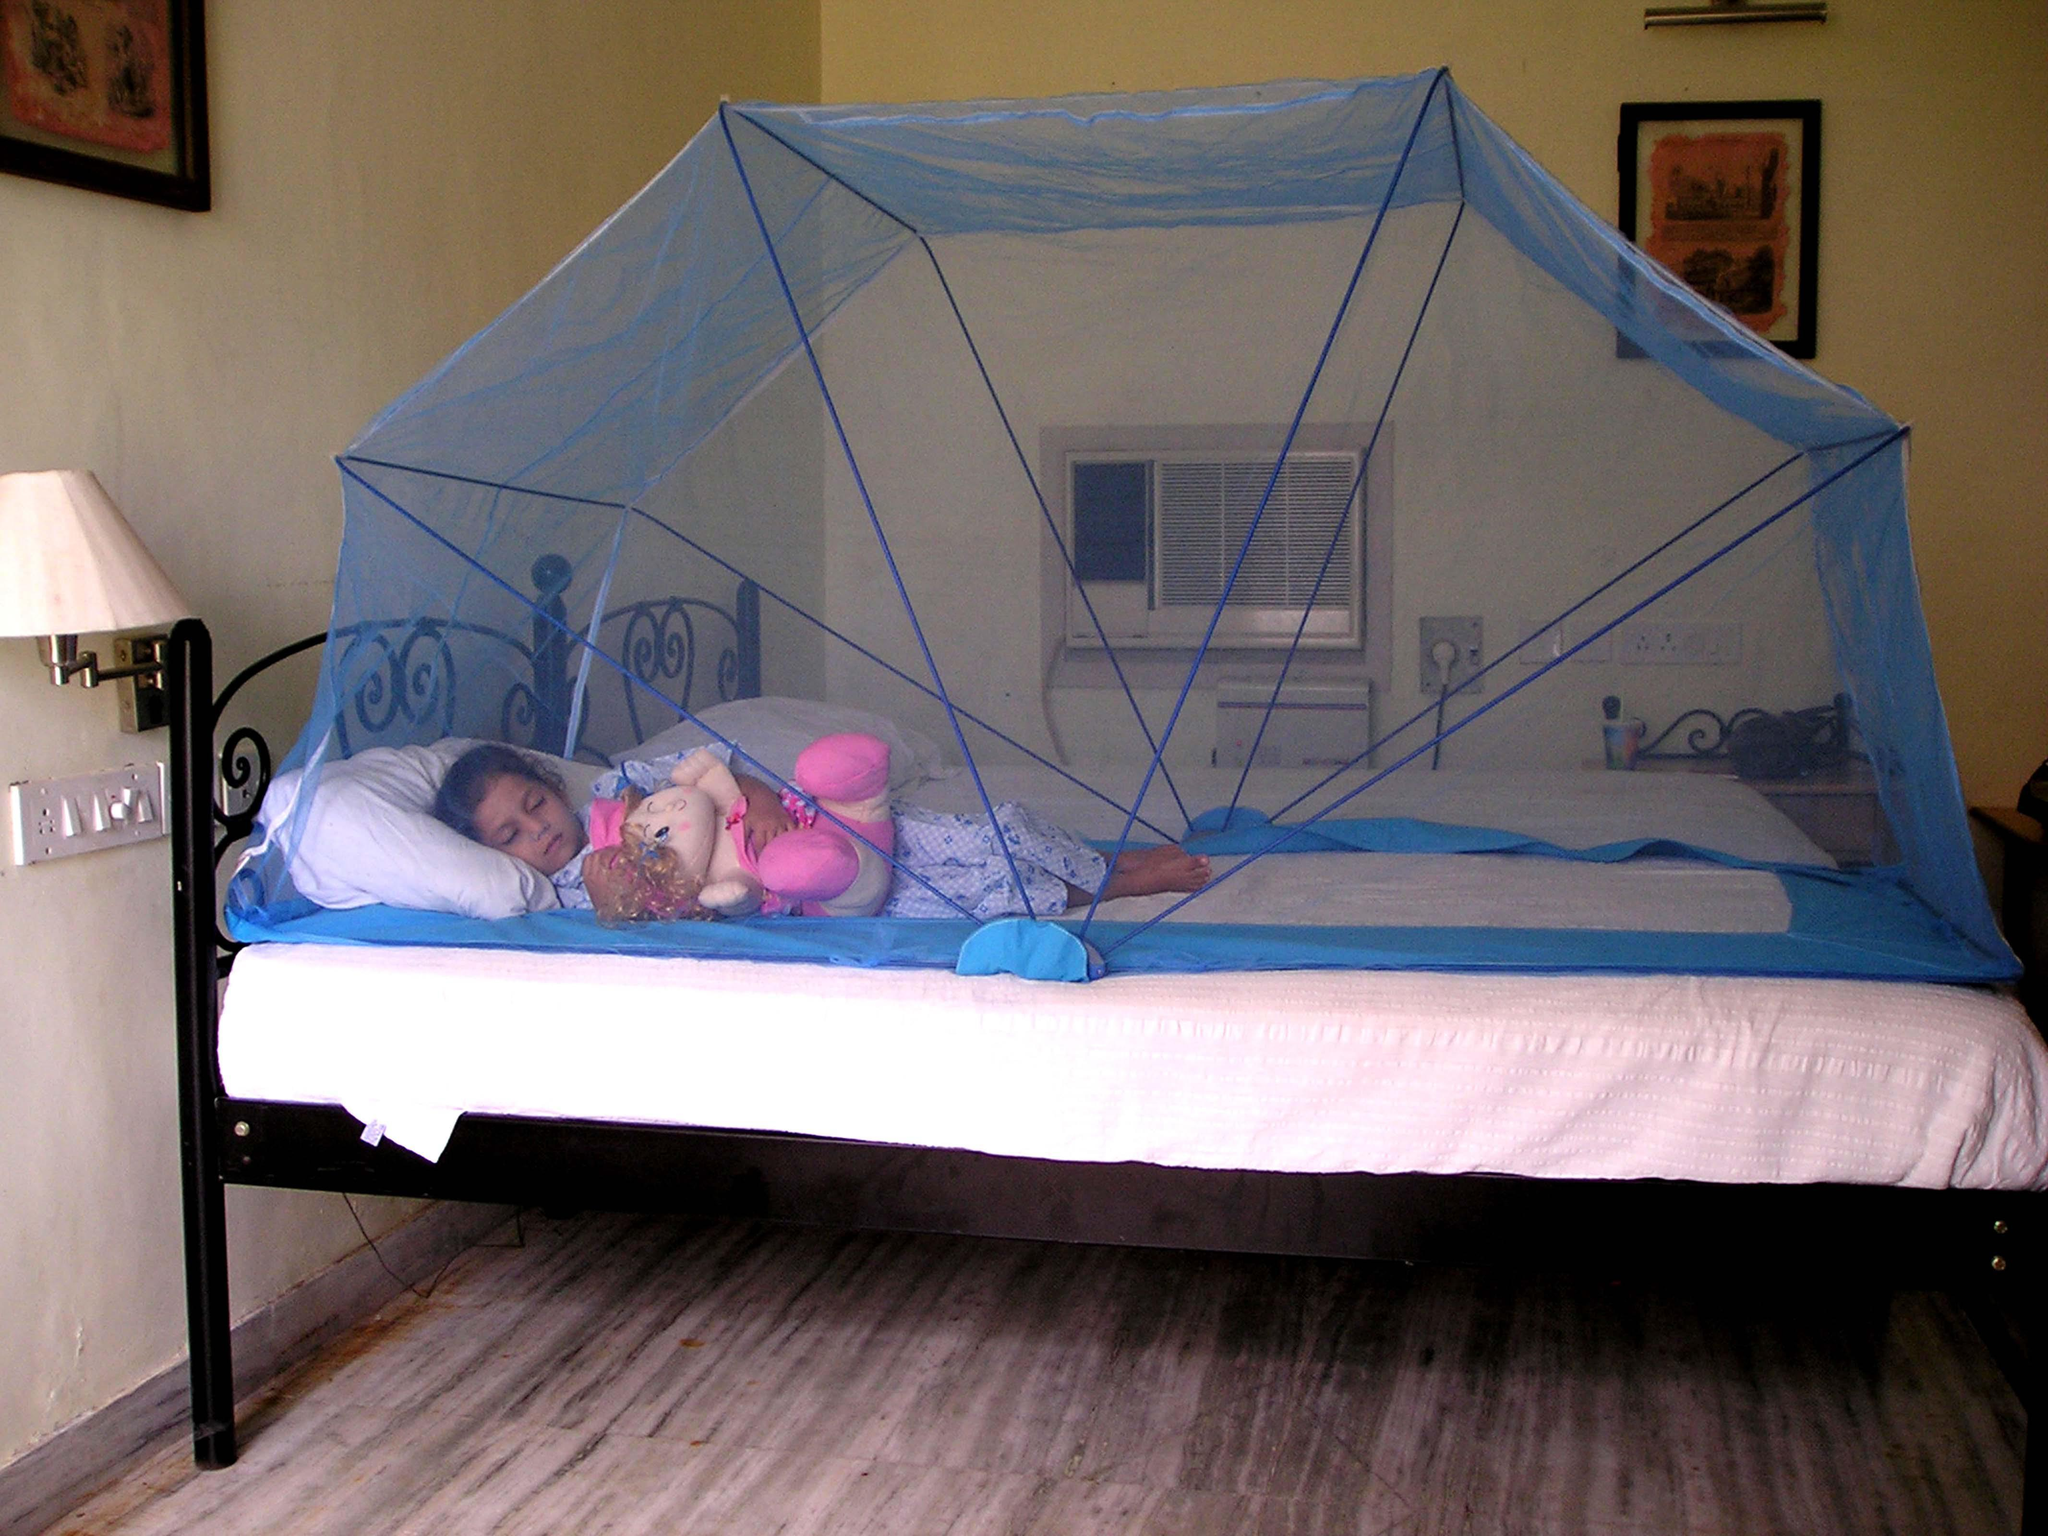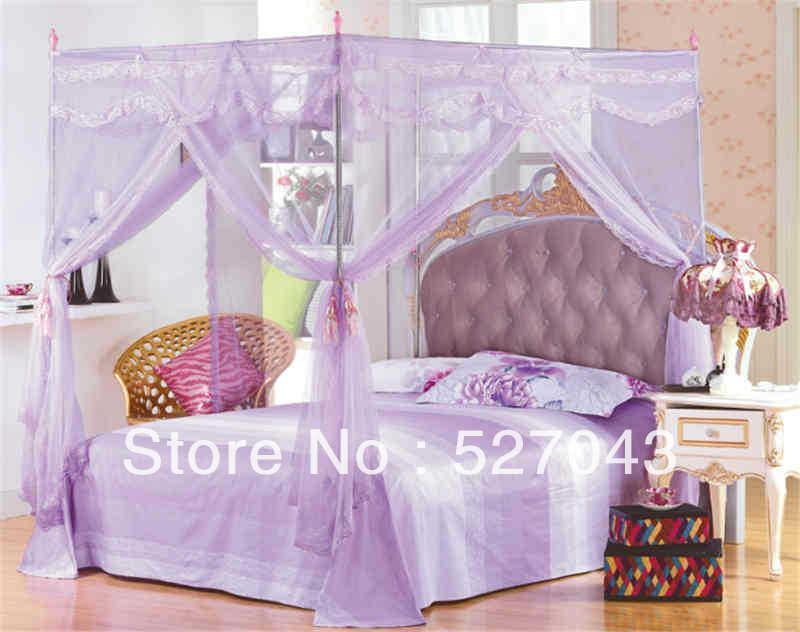The first image is the image on the left, the second image is the image on the right. Considering the images on both sides, is "Both nets enclose the beds." valid? Answer yes or no. No. The first image is the image on the left, the second image is the image on the right. Examine the images to the left and right. Is the description "Both images show beds with the same shape of overhead drapery, but differing in construction detailing and in color." accurate? Answer yes or no. No. 